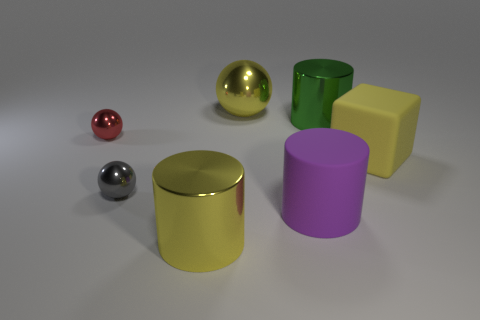How many gray objects are either spheres or tiny metal objects?
Offer a very short reply. 1. What number of large objects are on the right side of the large yellow shiny thing that is behind the yellow metallic cylinder?
Offer a very short reply. 3. What number of other things are there of the same shape as the big yellow rubber thing?
Offer a terse response. 0. What is the material of the cube that is the same color as the big metal sphere?
Provide a succinct answer. Rubber. What number of metal cylinders have the same color as the large cube?
Make the answer very short. 1. The other big object that is the same material as the purple thing is what color?
Your response must be concise. Yellow. Is there a green metal thing of the same size as the yellow sphere?
Your response must be concise. Yes. Is the number of big purple rubber cylinders that are on the right side of the small gray shiny thing greater than the number of purple matte objects that are to the left of the purple object?
Provide a succinct answer. Yes. Is the material of the small sphere that is behind the big yellow matte thing the same as the big yellow object that is on the right side of the large rubber cylinder?
Provide a short and direct response. No. There is a green object that is the same size as the cube; what shape is it?
Offer a terse response. Cylinder. 